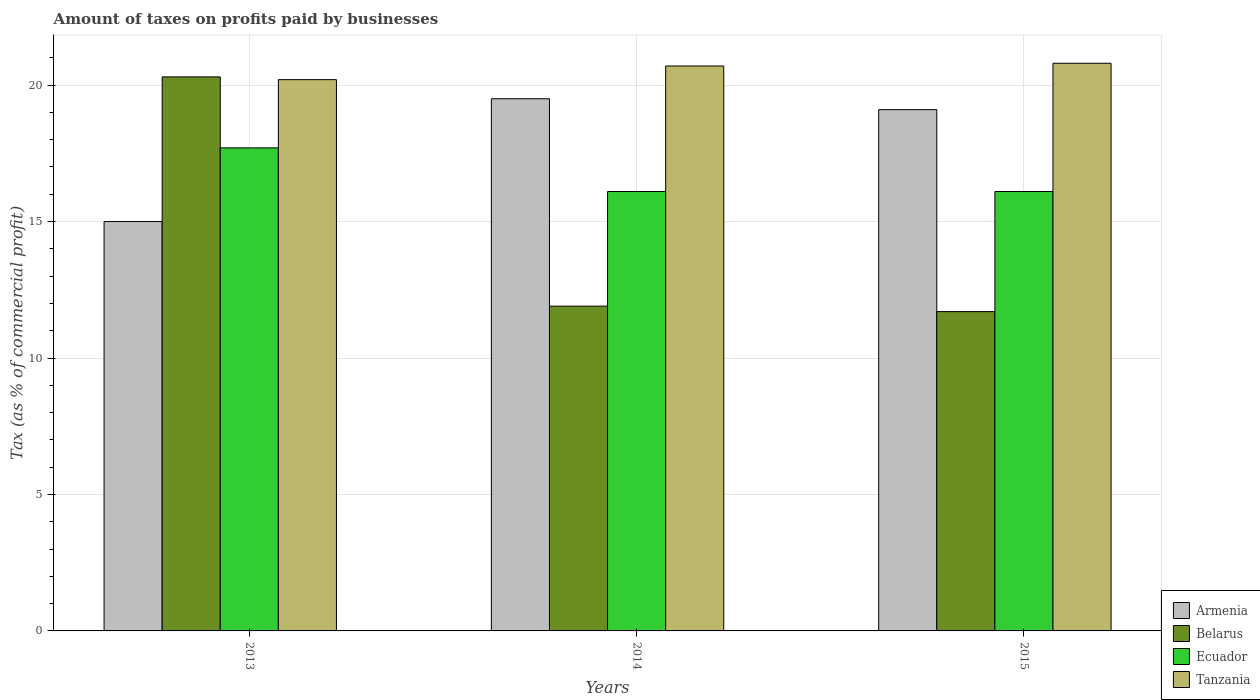How many different coloured bars are there?
Make the answer very short. 4. How many groups of bars are there?
Your answer should be very brief. 3. Are the number of bars on each tick of the X-axis equal?
Offer a very short reply. Yes. How many bars are there on the 3rd tick from the right?
Provide a short and direct response. 4. What is the percentage of taxes paid by businesses in Tanzania in 2015?
Offer a terse response. 20.8. Across all years, what is the minimum percentage of taxes paid by businesses in Armenia?
Your response must be concise. 15. In which year was the percentage of taxes paid by businesses in Ecuador maximum?
Your answer should be compact. 2013. In which year was the percentage of taxes paid by businesses in Armenia minimum?
Keep it short and to the point. 2013. What is the total percentage of taxes paid by businesses in Belarus in the graph?
Ensure brevity in your answer.  43.9. What is the difference between the percentage of taxes paid by businesses in Tanzania in 2014 and the percentage of taxes paid by businesses in Ecuador in 2013?
Your answer should be compact. 3. What is the average percentage of taxes paid by businesses in Armenia per year?
Offer a terse response. 17.87. In the year 2013, what is the difference between the percentage of taxes paid by businesses in Armenia and percentage of taxes paid by businesses in Belarus?
Make the answer very short. -5.3. What is the ratio of the percentage of taxes paid by businesses in Belarus in 2013 to that in 2014?
Make the answer very short. 1.71. Is the percentage of taxes paid by businesses in Tanzania in 2013 less than that in 2015?
Your answer should be compact. Yes. Is the difference between the percentage of taxes paid by businesses in Armenia in 2014 and 2015 greater than the difference between the percentage of taxes paid by businesses in Belarus in 2014 and 2015?
Keep it short and to the point. Yes. What is the difference between the highest and the second highest percentage of taxes paid by businesses in Armenia?
Offer a terse response. 0.4. What is the difference between the highest and the lowest percentage of taxes paid by businesses in Tanzania?
Offer a terse response. 0.6. In how many years, is the percentage of taxes paid by businesses in Ecuador greater than the average percentage of taxes paid by businesses in Ecuador taken over all years?
Keep it short and to the point. 1. Is the sum of the percentage of taxes paid by businesses in Belarus in 2014 and 2015 greater than the maximum percentage of taxes paid by businesses in Armenia across all years?
Ensure brevity in your answer.  Yes. What does the 1st bar from the left in 2013 represents?
Provide a succinct answer. Armenia. What does the 3rd bar from the right in 2015 represents?
Give a very brief answer. Belarus. Is it the case that in every year, the sum of the percentage of taxes paid by businesses in Ecuador and percentage of taxes paid by businesses in Armenia is greater than the percentage of taxes paid by businesses in Belarus?
Ensure brevity in your answer.  Yes. How many bars are there?
Offer a terse response. 12. Are all the bars in the graph horizontal?
Your answer should be compact. No. How many years are there in the graph?
Offer a very short reply. 3. Does the graph contain grids?
Offer a very short reply. Yes. How are the legend labels stacked?
Your answer should be very brief. Vertical. What is the title of the graph?
Your answer should be very brief. Amount of taxes on profits paid by businesses. Does "Canada" appear as one of the legend labels in the graph?
Provide a short and direct response. No. What is the label or title of the X-axis?
Offer a terse response. Years. What is the label or title of the Y-axis?
Your answer should be very brief. Tax (as % of commercial profit). What is the Tax (as % of commercial profit) of Belarus in 2013?
Offer a terse response. 20.3. What is the Tax (as % of commercial profit) in Tanzania in 2013?
Your response must be concise. 20.2. What is the Tax (as % of commercial profit) of Armenia in 2014?
Offer a terse response. 19.5. What is the Tax (as % of commercial profit) of Ecuador in 2014?
Make the answer very short. 16.1. What is the Tax (as % of commercial profit) of Tanzania in 2014?
Provide a succinct answer. 20.7. What is the Tax (as % of commercial profit) in Armenia in 2015?
Provide a short and direct response. 19.1. What is the Tax (as % of commercial profit) in Belarus in 2015?
Your answer should be very brief. 11.7. What is the Tax (as % of commercial profit) in Ecuador in 2015?
Offer a terse response. 16.1. What is the Tax (as % of commercial profit) of Tanzania in 2015?
Your answer should be very brief. 20.8. Across all years, what is the maximum Tax (as % of commercial profit) of Belarus?
Make the answer very short. 20.3. Across all years, what is the maximum Tax (as % of commercial profit) in Tanzania?
Make the answer very short. 20.8. Across all years, what is the minimum Tax (as % of commercial profit) of Armenia?
Your response must be concise. 15. Across all years, what is the minimum Tax (as % of commercial profit) of Tanzania?
Make the answer very short. 20.2. What is the total Tax (as % of commercial profit) of Armenia in the graph?
Make the answer very short. 53.6. What is the total Tax (as % of commercial profit) in Belarus in the graph?
Ensure brevity in your answer.  43.9. What is the total Tax (as % of commercial profit) of Ecuador in the graph?
Your response must be concise. 49.9. What is the total Tax (as % of commercial profit) of Tanzania in the graph?
Keep it short and to the point. 61.7. What is the difference between the Tax (as % of commercial profit) of Armenia in 2013 and that in 2014?
Make the answer very short. -4.5. What is the difference between the Tax (as % of commercial profit) of Ecuador in 2013 and that in 2014?
Your answer should be very brief. 1.6. What is the difference between the Tax (as % of commercial profit) in Armenia in 2013 and that in 2015?
Keep it short and to the point. -4.1. What is the difference between the Tax (as % of commercial profit) in Armenia in 2014 and that in 2015?
Make the answer very short. 0.4. What is the difference between the Tax (as % of commercial profit) of Tanzania in 2014 and that in 2015?
Your answer should be very brief. -0.1. What is the difference between the Tax (as % of commercial profit) in Armenia in 2013 and the Tax (as % of commercial profit) in Belarus in 2014?
Give a very brief answer. 3.1. What is the difference between the Tax (as % of commercial profit) in Armenia in 2013 and the Tax (as % of commercial profit) in Ecuador in 2014?
Provide a short and direct response. -1.1. What is the difference between the Tax (as % of commercial profit) of Belarus in 2013 and the Tax (as % of commercial profit) of Ecuador in 2014?
Offer a terse response. 4.2. What is the difference between the Tax (as % of commercial profit) of Armenia in 2013 and the Tax (as % of commercial profit) of Ecuador in 2015?
Offer a very short reply. -1.1. What is the difference between the Tax (as % of commercial profit) in Armenia in 2013 and the Tax (as % of commercial profit) in Tanzania in 2015?
Provide a succinct answer. -5.8. What is the difference between the Tax (as % of commercial profit) of Belarus in 2013 and the Tax (as % of commercial profit) of Tanzania in 2015?
Provide a succinct answer. -0.5. What is the difference between the Tax (as % of commercial profit) of Ecuador in 2013 and the Tax (as % of commercial profit) of Tanzania in 2015?
Keep it short and to the point. -3.1. What is the difference between the Tax (as % of commercial profit) in Armenia in 2014 and the Tax (as % of commercial profit) in Belarus in 2015?
Your answer should be compact. 7.8. What is the difference between the Tax (as % of commercial profit) of Ecuador in 2014 and the Tax (as % of commercial profit) of Tanzania in 2015?
Your answer should be compact. -4.7. What is the average Tax (as % of commercial profit) of Armenia per year?
Keep it short and to the point. 17.87. What is the average Tax (as % of commercial profit) in Belarus per year?
Your response must be concise. 14.63. What is the average Tax (as % of commercial profit) of Ecuador per year?
Provide a short and direct response. 16.63. What is the average Tax (as % of commercial profit) of Tanzania per year?
Provide a short and direct response. 20.57. In the year 2013, what is the difference between the Tax (as % of commercial profit) of Armenia and Tax (as % of commercial profit) of Ecuador?
Ensure brevity in your answer.  -2.7. In the year 2013, what is the difference between the Tax (as % of commercial profit) of Armenia and Tax (as % of commercial profit) of Tanzania?
Your answer should be very brief. -5.2. In the year 2013, what is the difference between the Tax (as % of commercial profit) in Belarus and Tax (as % of commercial profit) in Ecuador?
Make the answer very short. 2.6. In the year 2014, what is the difference between the Tax (as % of commercial profit) of Armenia and Tax (as % of commercial profit) of Tanzania?
Make the answer very short. -1.2. In the year 2014, what is the difference between the Tax (as % of commercial profit) of Belarus and Tax (as % of commercial profit) of Tanzania?
Your response must be concise. -8.8. In the year 2014, what is the difference between the Tax (as % of commercial profit) of Ecuador and Tax (as % of commercial profit) of Tanzania?
Provide a succinct answer. -4.6. In the year 2015, what is the difference between the Tax (as % of commercial profit) in Armenia and Tax (as % of commercial profit) in Belarus?
Offer a very short reply. 7.4. What is the ratio of the Tax (as % of commercial profit) in Armenia in 2013 to that in 2014?
Keep it short and to the point. 0.77. What is the ratio of the Tax (as % of commercial profit) in Belarus in 2013 to that in 2014?
Your answer should be compact. 1.71. What is the ratio of the Tax (as % of commercial profit) in Ecuador in 2013 to that in 2014?
Provide a succinct answer. 1.1. What is the ratio of the Tax (as % of commercial profit) of Tanzania in 2013 to that in 2014?
Ensure brevity in your answer.  0.98. What is the ratio of the Tax (as % of commercial profit) in Armenia in 2013 to that in 2015?
Offer a very short reply. 0.79. What is the ratio of the Tax (as % of commercial profit) in Belarus in 2013 to that in 2015?
Give a very brief answer. 1.74. What is the ratio of the Tax (as % of commercial profit) of Ecuador in 2013 to that in 2015?
Provide a succinct answer. 1.1. What is the ratio of the Tax (as % of commercial profit) of Tanzania in 2013 to that in 2015?
Ensure brevity in your answer.  0.97. What is the ratio of the Tax (as % of commercial profit) of Armenia in 2014 to that in 2015?
Your answer should be compact. 1.02. What is the ratio of the Tax (as % of commercial profit) of Belarus in 2014 to that in 2015?
Make the answer very short. 1.02. What is the ratio of the Tax (as % of commercial profit) in Ecuador in 2014 to that in 2015?
Offer a terse response. 1. What is the ratio of the Tax (as % of commercial profit) of Tanzania in 2014 to that in 2015?
Make the answer very short. 1. What is the difference between the highest and the second highest Tax (as % of commercial profit) of Armenia?
Your response must be concise. 0.4. What is the difference between the highest and the second highest Tax (as % of commercial profit) in Belarus?
Offer a very short reply. 8.4. What is the difference between the highest and the second highest Tax (as % of commercial profit) of Ecuador?
Keep it short and to the point. 1.6. What is the difference between the highest and the second highest Tax (as % of commercial profit) in Tanzania?
Your answer should be very brief. 0.1. What is the difference between the highest and the lowest Tax (as % of commercial profit) of Armenia?
Make the answer very short. 4.5. 